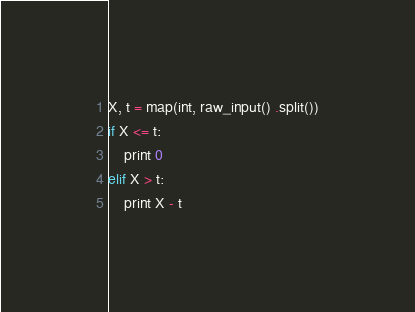<code> <loc_0><loc_0><loc_500><loc_500><_Python_>X, t = map(int, raw_input() .split())
if X <= t:
    print 0
elif X > t:
    print X - t
</code> 